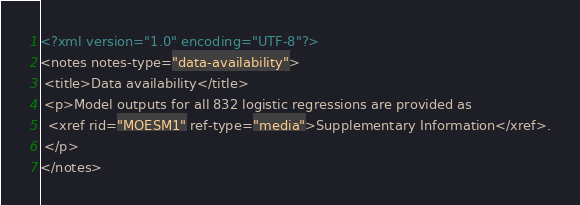<code> <loc_0><loc_0><loc_500><loc_500><_XML_><?xml version="1.0" encoding="UTF-8"?>
<notes notes-type="data-availability">
 <title>Data availability</title>
 <p>Model outputs for all 832 logistic regressions are provided as 
  <xref rid="MOESM1" ref-type="media">Supplementary Information</xref>.
 </p>
</notes>
</code> 